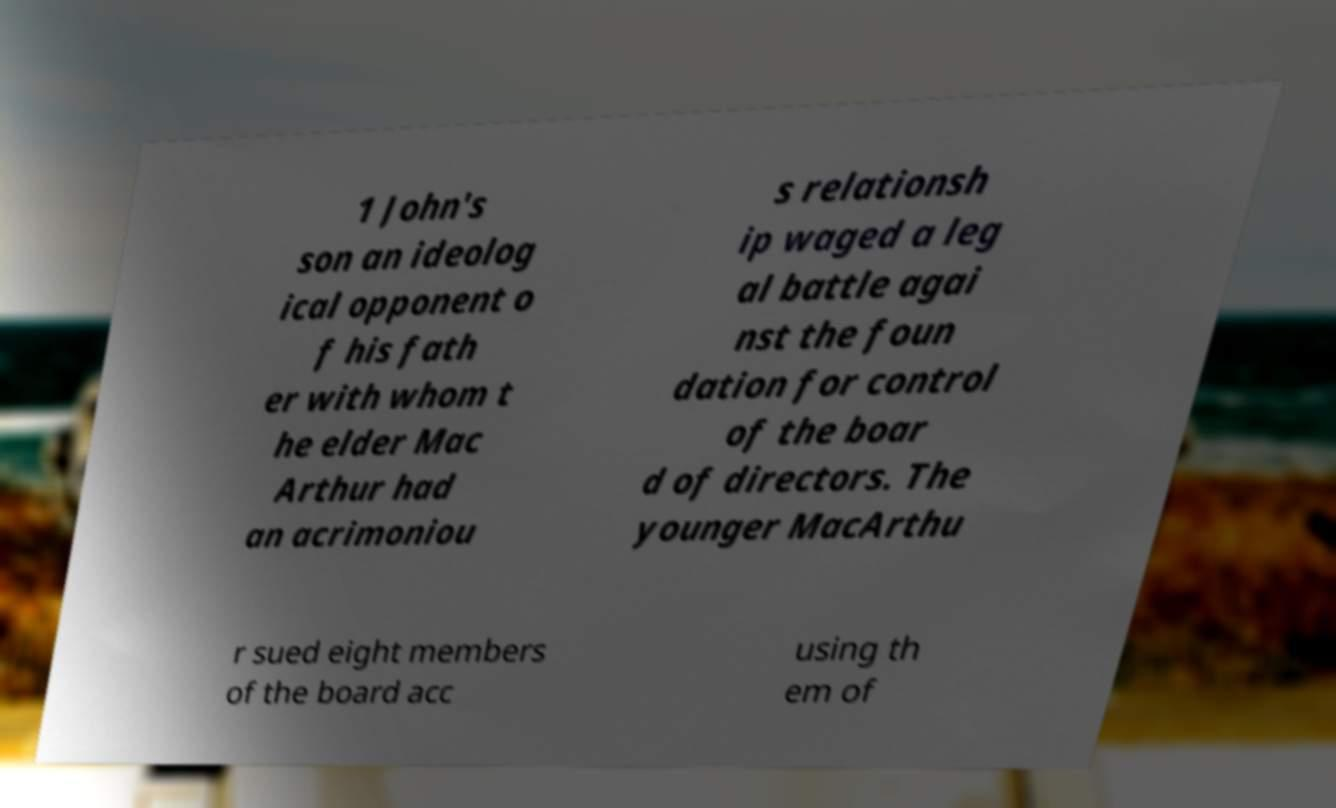For documentation purposes, I need the text within this image transcribed. Could you provide that? 1 John's son an ideolog ical opponent o f his fath er with whom t he elder Mac Arthur had an acrimoniou s relationsh ip waged a leg al battle agai nst the foun dation for control of the boar d of directors. The younger MacArthu r sued eight members of the board acc using th em of 